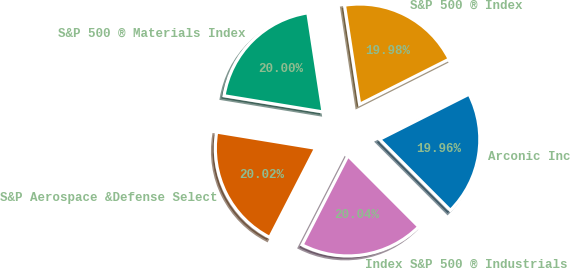Convert chart. <chart><loc_0><loc_0><loc_500><loc_500><pie_chart><fcel>Arconic Inc<fcel>S&P 500 ® Index<fcel>S&P 500 ® Materials Index<fcel>S&P Aerospace &Defense Select<fcel>Index S&P 500 ® Industrials<nl><fcel>19.96%<fcel>19.98%<fcel>20.0%<fcel>20.02%<fcel>20.04%<nl></chart> 